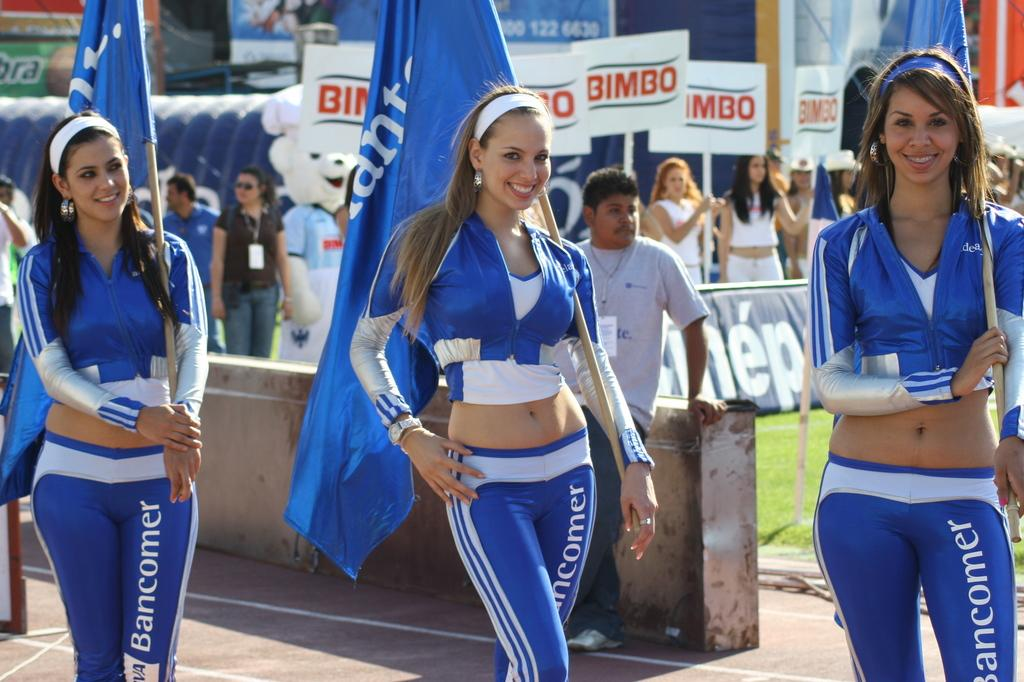<image>
Write a terse but informative summary of the picture. Women in outfits carrying flags in front of bimbo signs 